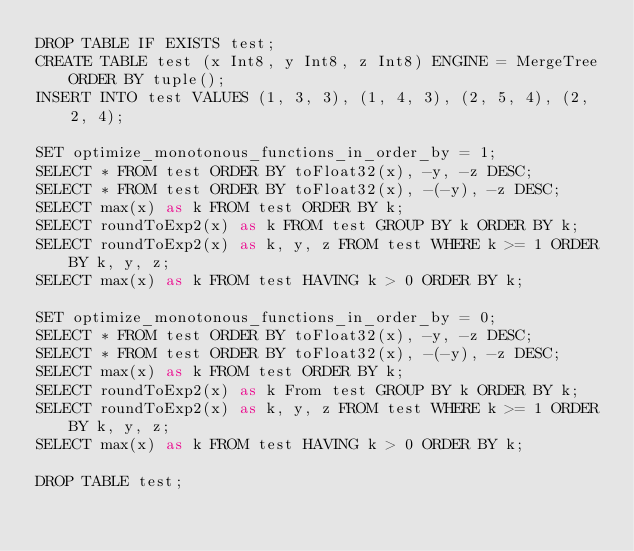Convert code to text. <code><loc_0><loc_0><loc_500><loc_500><_SQL_>DROP TABLE IF EXISTS test;
CREATE TABLE test (x Int8, y Int8, z Int8) ENGINE = MergeTree ORDER BY tuple();
INSERT INTO test VALUES (1, 3, 3), (1, 4, 3), (2, 5, 4), (2, 2, 4);

SET optimize_monotonous_functions_in_order_by = 1;
SELECT * FROM test ORDER BY toFloat32(x), -y, -z DESC;
SELECT * FROM test ORDER BY toFloat32(x), -(-y), -z DESC;
SELECT max(x) as k FROM test ORDER BY k;
SELECT roundToExp2(x) as k FROM test GROUP BY k ORDER BY k;
SELECT roundToExp2(x) as k, y, z FROM test WHERE k >= 1 ORDER BY k, y, z;
SELECT max(x) as k FROM test HAVING k > 0 ORDER BY k;

SET optimize_monotonous_functions_in_order_by = 0;
SELECT * FROM test ORDER BY toFloat32(x), -y, -z DESC;
SELECT * FROM test ORDER BY toFloat32(x), -(-y), -z DESC;
SELECT max(x) as k FROM test ORDER BY k;
SELECT roundToExp2(x) as k From test GROUP BY k ORDER BY k;
SELECT roundToExp2(x) as k, y, z FROM test WHERE k >= 1 ORDER BY k, y, z;
SELECT max(x) as k FROM test HAVING k > 0 ORDER BY k;

DROP TABLE test;
</code> 